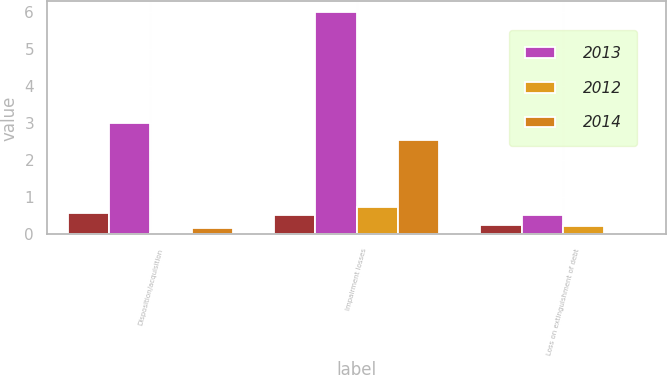Convert chart to OTSL. <chart><loc_0><loc_0><loc_500><loc_500><stacked_bar_chart><ecel><fcel>Disposition/acquisition<fcel>Impairment losses<fcel>Loss on extinguishment of debt<nl><fcel>nan<fcel>0.59<fcel>0.53<fcel>0.25<nl><fcel>2013<fcel>3<fcel>6<fcel>0.53<nl><fcel>2012<fcel>0.03<fcel>0.75<fcel>0.22<nl><fcel>2014<fcel>0.18<fcel>2.55<fcel>0.01<nl></chart> 